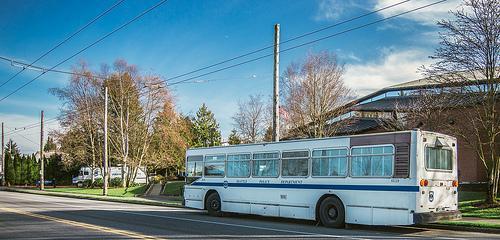How many buses are there?
Give a very brief answer. 1. How many windows are on the side of the bus?
Give a very brief answer. 7. 